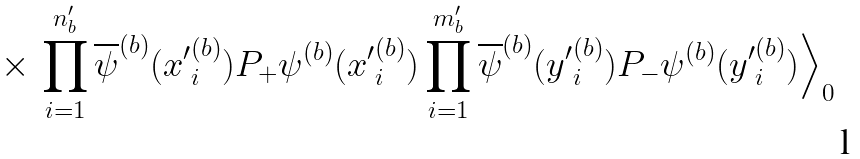Convert formula to latex. <formula><loc_0><loc_0><loc_500><loc_500>\times \, \prod _ { i = 1 } ^ { n _ { b } ^ { \prime } } \overline { \psi } ^ { ( b ) } ( { x ^ { \prime } } _ { i } ^ { ( b ) } ) P _ { + } \psi ^ { ( b ) } ( { x ^ { \prime } } _ { i } ^ { ( b ) } ) \prod _ { i = 1 } ^ { m _ { b } ^ { \prime } } \overline { \psi } ^ { ( b ) } ( { y ^ { \prime } } _ { i } ^ { ( b ) } ) P _ { - } \psi ^ { ( b ) } ( { y ^ { \prime } } _ { i } ^ { ( b ) } ) \Big \rangle _ { 0 }</formula> 